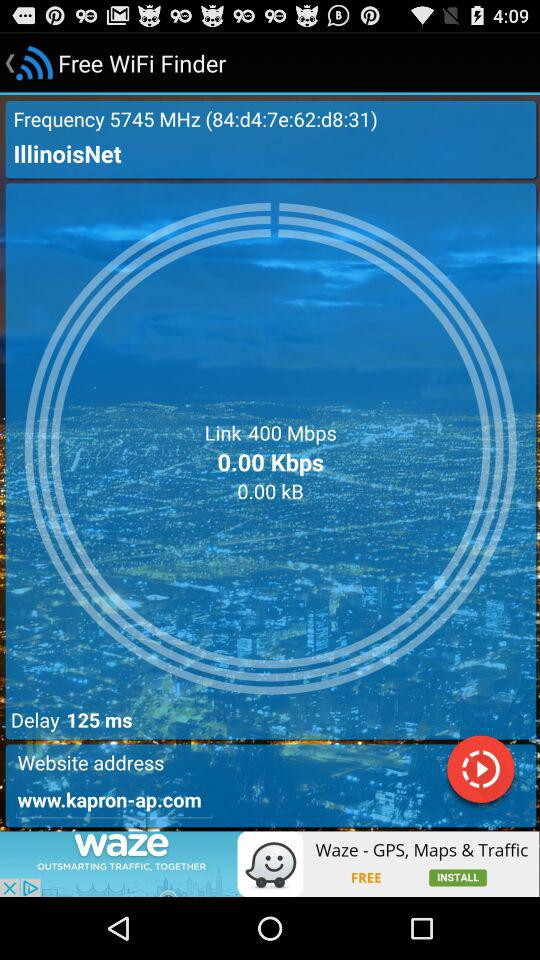What is the name of the application? The name of the application is "Free WiFi Finder". 